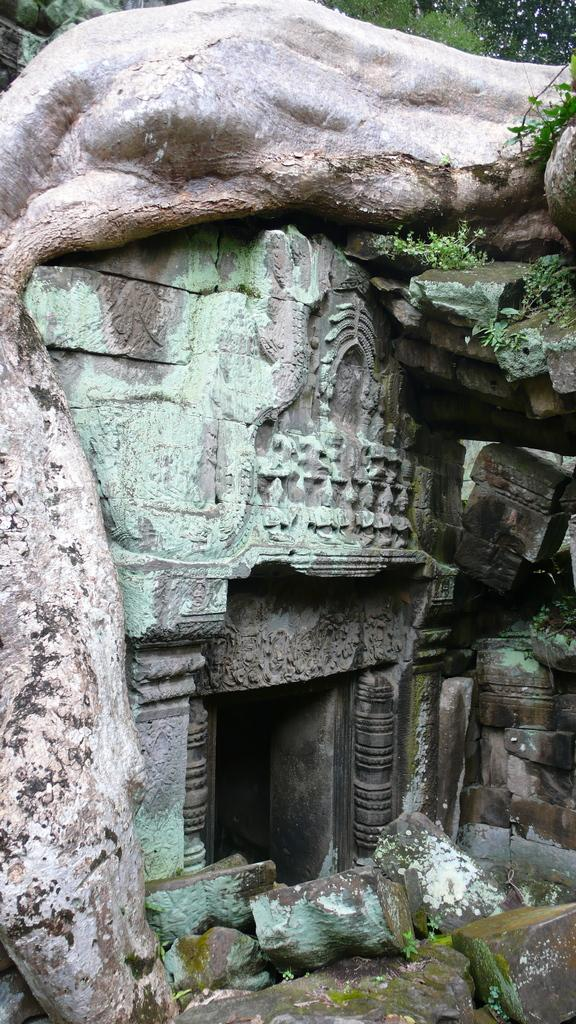What can be seen on the wall in the image? There is a wall with sculptures carved in the image. What type of natural elements are visible in the image? There are rocks and trees visible in the image. Can you describe the tree trunk in the image? The trunk of a tree is present in the image. How many trees can be seen in the image? There are trees in the image. What type of sweater is the tree wearing in the image? There is no sweater present in the image; it features a tree trunk and trees. How does the mind system work in the image? There is no mention of a mind system in the image; it focuses on a wall with sculptures, rocks, and trees. 